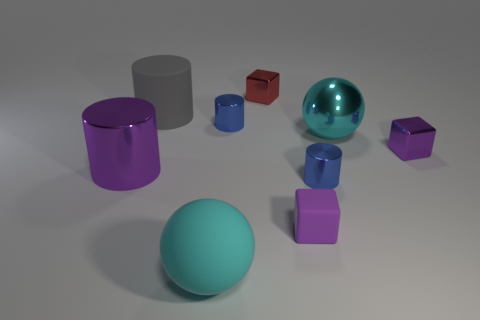Add 1 large metallic balls. How many objects exist? 10 Subtract all cyan cylinders. Subtract all cyan balls. How many cylinders are left? 4 Subtract all balls. How many objects are left? 7 Add 7 big yellow things. How many big yellow things exist? 7 Subtract 0 brown cylinders. How many objects are left? 9 Subtract all tiny green metal objects. Subtract all purple matte blocks. How many objects are left? 8 Add 5 big cylinders. How many big cylinders are left? 7 